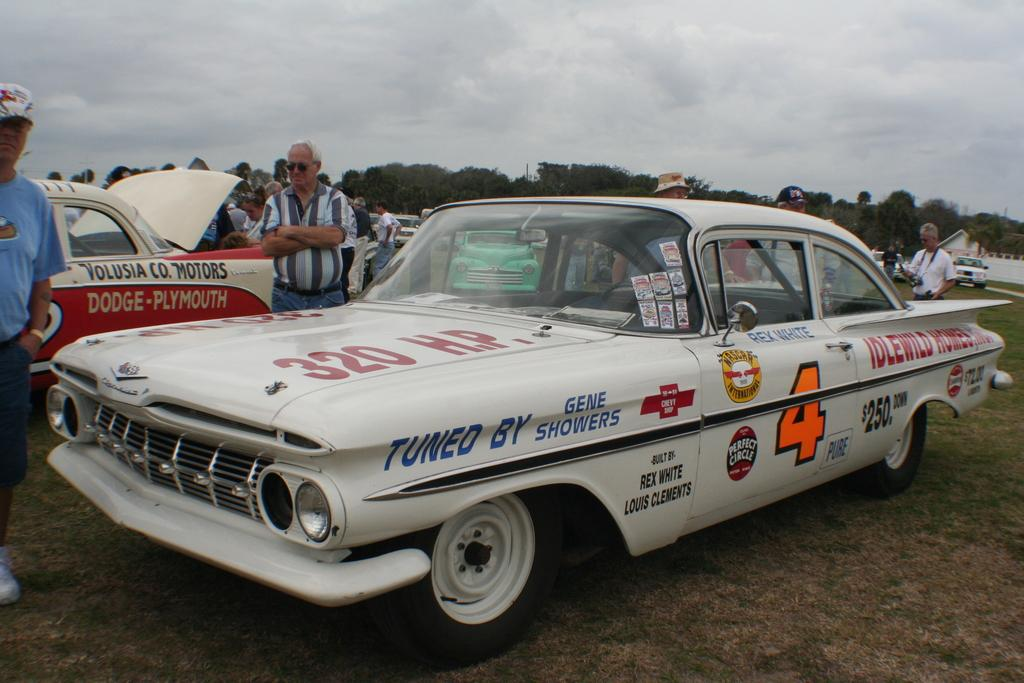What can be seen in the image? There are vehicles and people in the image. How are the vehicles different from each other? The vehicles are in different colors. What are the people in the image doing? Some people are standing, and some are holding something. What can be seen in the background of the image? There are trees, a house, and a cloudy sky visible in the background. Can you see anyone kicking a bucket in the image? There is no bucket or anyone kicking in the image. 